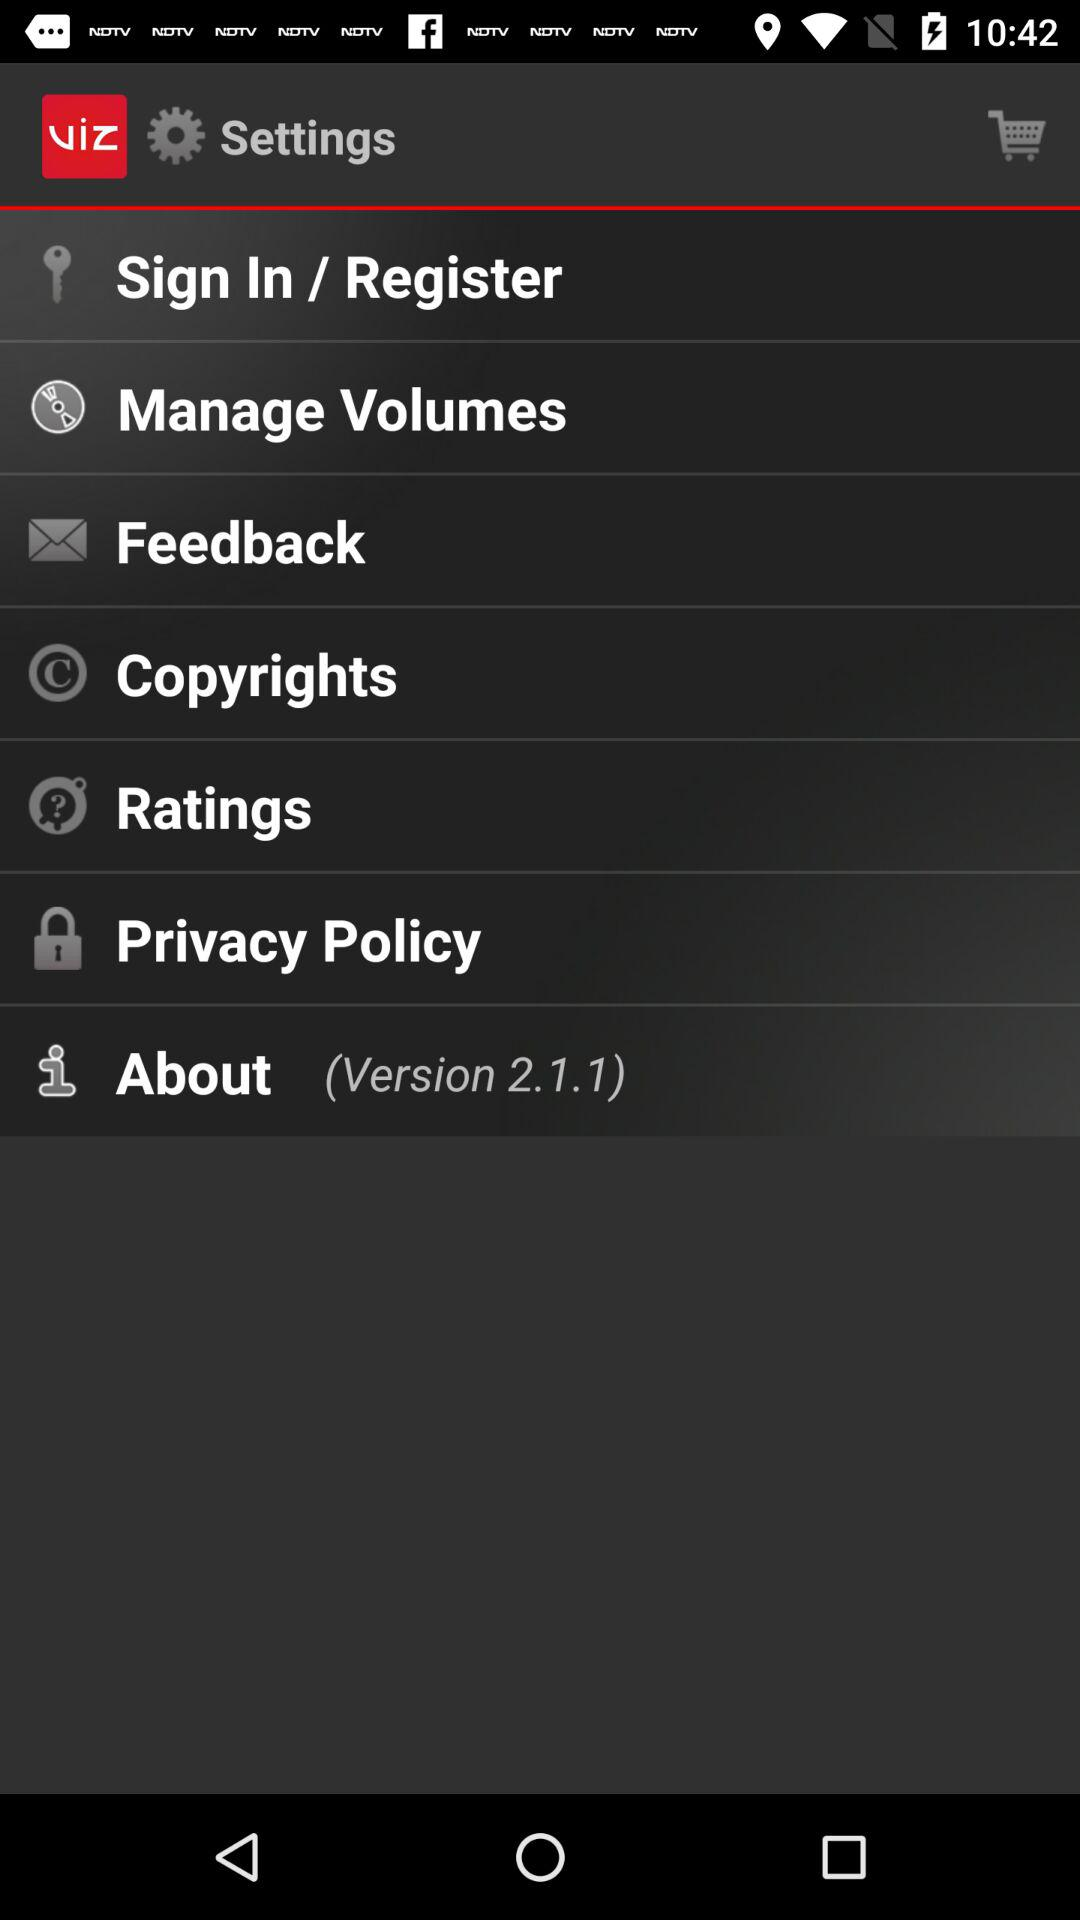What is the application name? The application name is "viz". 